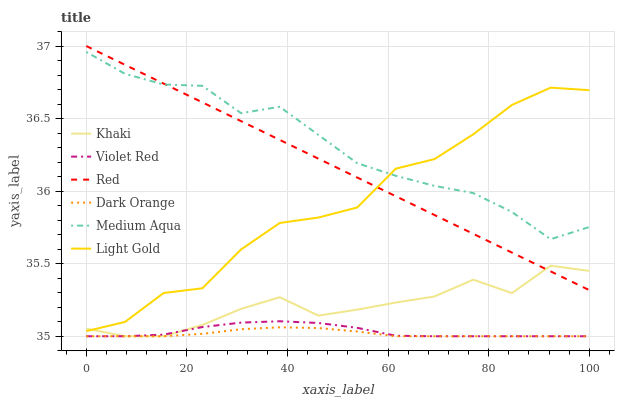Does Dark Orange have the minimum area under the curve?
Answer yes or no. Yes. Does Medium Aqua have the maximum area under the curve?
Answer yes or no. Yes. Does Violet Red have the minimum area under the curve?
Answer yes or no. No. Does Violet Red have the maximum area under the curve?
Answer yes or no. No. Is Red the smoothest?
Answer yes or no. Yes. Is Light Gold the roughest?
Answer yes or no. Yes. Is Violet Red the smoothest?
Answer yes or no. No. Is Violet Red the roughest?
Answer yes or no. No. Does Dark Orange have the lowest value?
Answer yes or no. Yes. Does Medium Aqua have the lowest value?
Answer yes or no. No. Does Red have the highest value?
Answer yes or no. Yes. Does Violet Red have the highest value?
Answer yes or no. No. Is Dark Orange less than Medium Aqua?
Answer yes or no. Yes. Is Medium Aqua greater than Violet Red?
Answer yes or no. Yes. Does Red intersect Medium Aqua?
Answer yes or no. Yes. Is Red less than Medium Aqua?
Answer yes or no. No. Is Red greater than Medium Aqua?
Answer yes or no. No. Does Dark Orange intersect Medium Aqua?
Answer yes or no. No. 